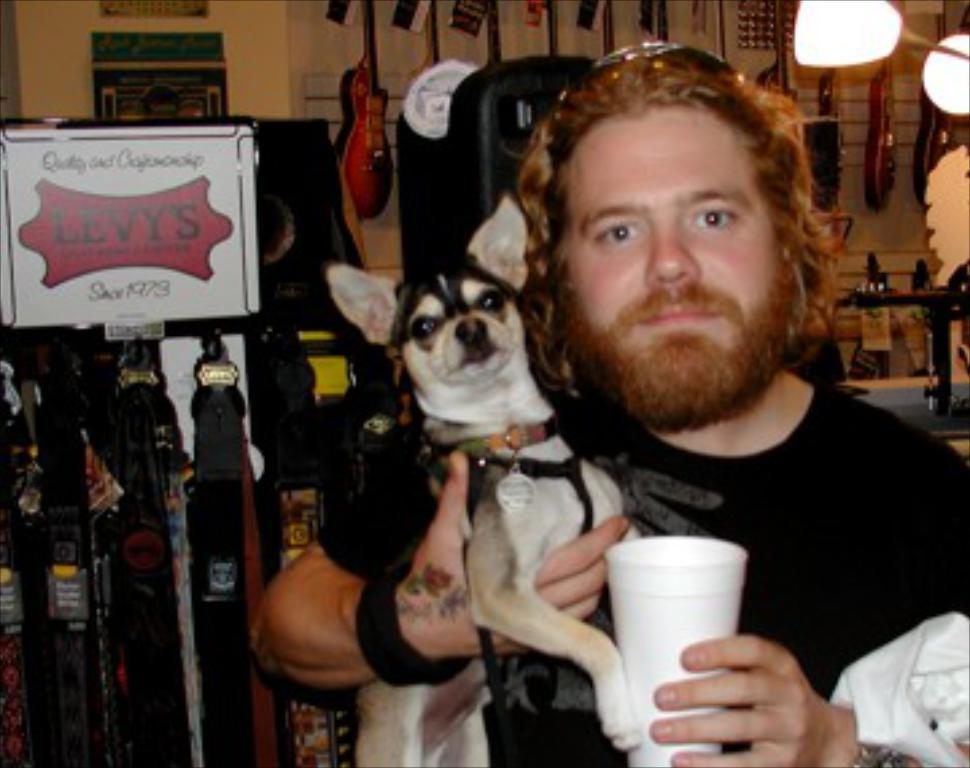What is the man in the image holding? The man is holding a glass in the image. What other living creature is present in the image? There is a dog in the image. What can be seen in the background of the image? In the background, there is a board, musical instruments hanging, a light, and a wall. What type of magic is the man performing with the glass in the image? There is no indication of magic or any magical performance in the image. The man is simply holding a glass. 